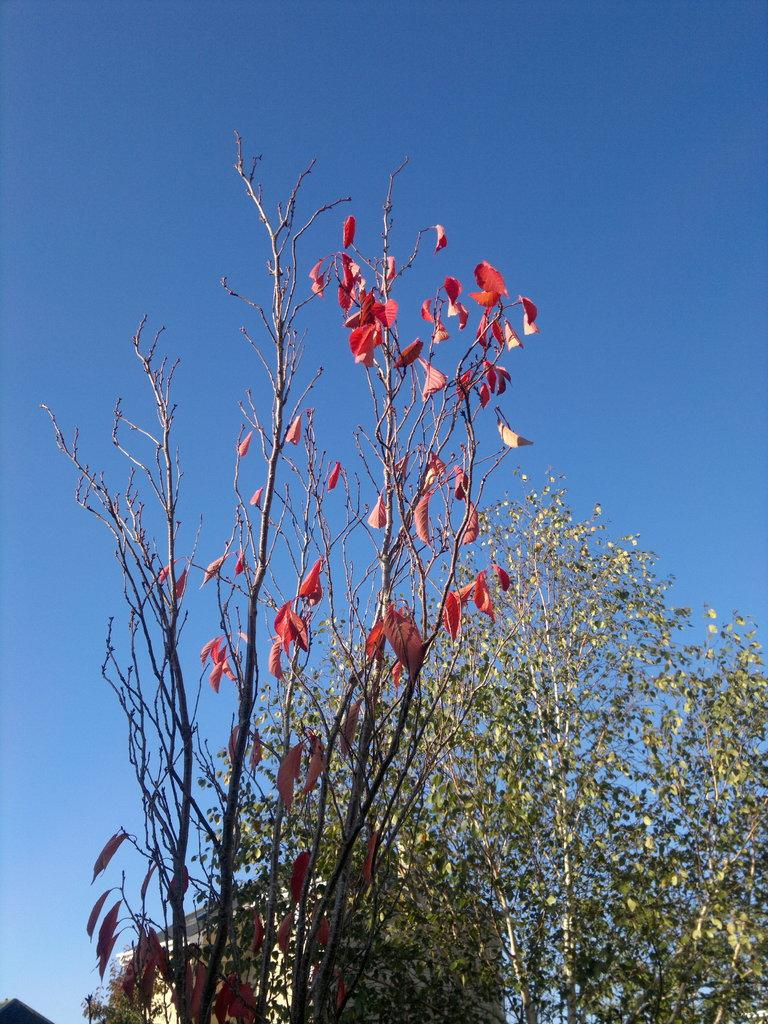What type of vegetation can be seen in the image? There are trees in the image. What is visible at the top of the image? The sky is visible at the top of the image. How many gloves can be seen hanging from the trees in the image? There are no gloves present in the image; it only features trees and the sky. Is there a donkey visible in the image? No, there is no donkey present in the image. 